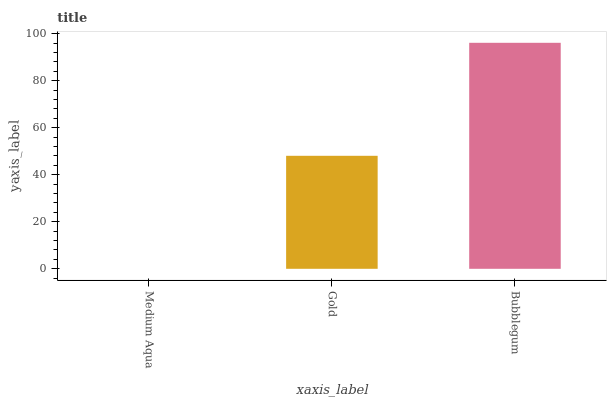Is Medium Aqua the minimum?
Answer yes or no. Yes. Is Bubblegum the maximum?
Answer yes or no. Yes. Is Gold the minimum?
Answer yes or no. No. Is Gold the maximum?
Answer yes or no. No. Is Gold greater than Medium Aqua?
Answer yes or no. Yes. Is Medium Aqua less than Gold?
Answer yes or no. Yes. Is Medium Aqua greater than Gold?
Answer yes or no. No. Is Gold less than Medium Aqua?
Answer yes or no. No. Is Gold the high median?
Answer yes or no. Yes. Is Gold the low median?
Answer yes or no. Yes. Is Bubblegum the high median?
Answer yes or no. No. Is Medium Aqua the low median?
Answer yes or no. No. 